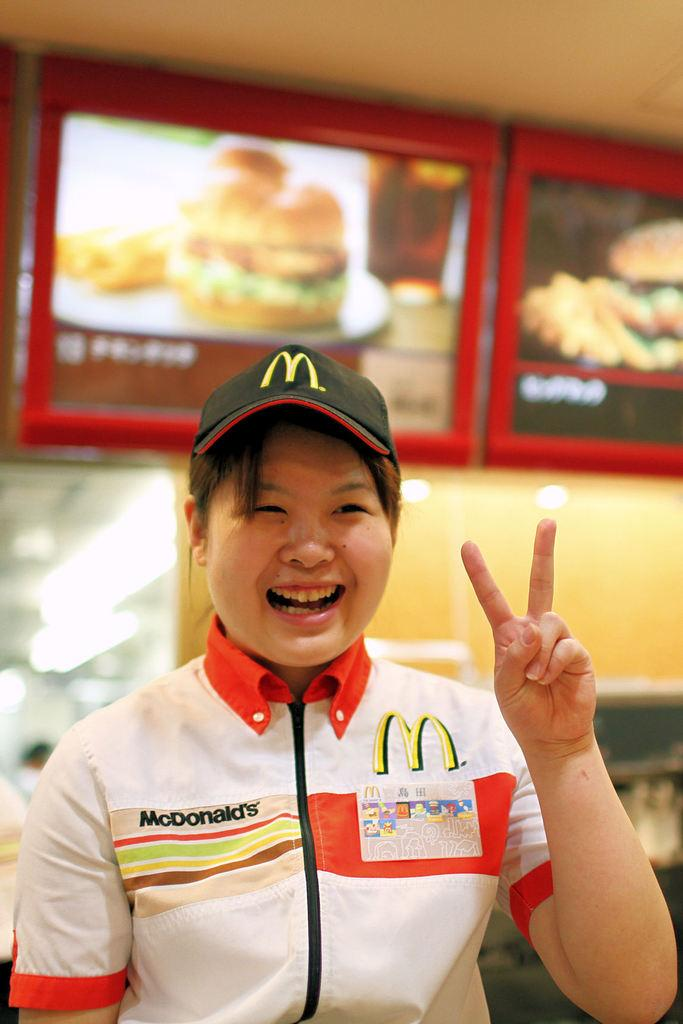Who is present in the image? There is a woman in the image. What is the woman wearing on her head? The woman is wearing a cap. What color is the shirt the woman is wearing? The woman is wearing a white shirt. What can be seen on the wall in the background of the image? There are screens on the wall in the background of the image. What type of wool is the woman using to knit in the image? There is no wool or knitting activity present in the image. What time of day is it in the image? The time of day cannot be determined from the image, as there are no clues to suggest morning or any other specific time. 